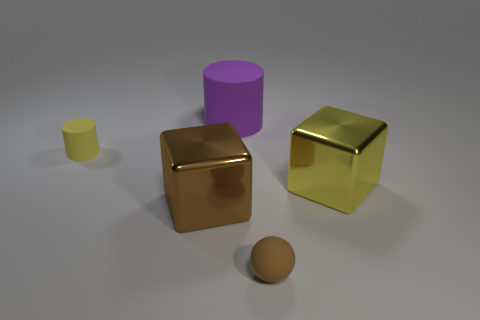Subtract all spheres. How many objects are left? 4 Subtract all brown blocks. How many blocks are left? 1 Add 1 yellow rubber objects. How many yellow rubber objects exist? 2 Add 3 large matte cylinders. How many objects exist? 8 Subtract 1 brown spheres. How many objects are left? 4 Subtract 1 cubes. How many cubes are left? 1 Subtract all green spheres. Subtract all red blocks. How many spheres are left? 1 Subtract all yellow blocks. How many cyan cylinders are left? 0 Subtract all small yellow cylinders. Subtract all small balls. How many objects are left? 3 Add 4 metallic objects. How many metallic objects are left? 6 